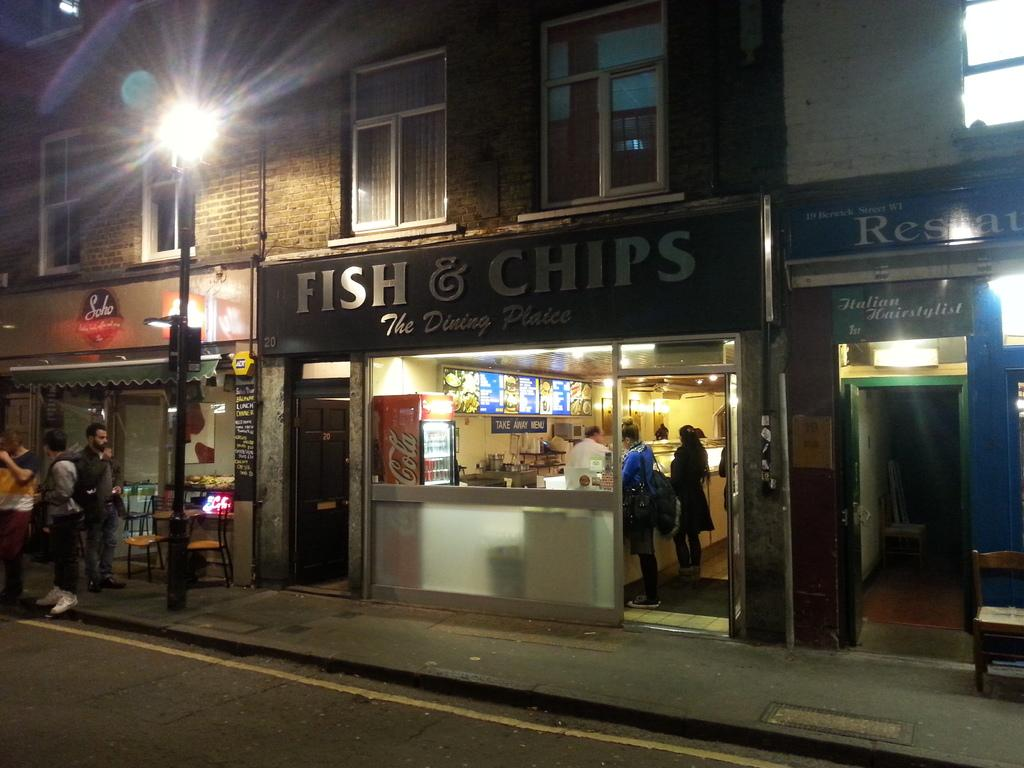What type of structures can be seen in the image? There are buildings in the image. What architectural features are visible on the buildings? There are windows in the image. What type of advertisements are present in the image? There are hoardings in the image. What type of establishments can be found in the image? There are stores in the image. Who or what is present in the image? There are people in the image. What type of furniture is visible in the image? There are chairs and tables in the image. What type of vertical structure is present in the image? There is a light pole in the image. What type of appliance can be seen in the image? There is a fridge in the image. What type of display is present in the image? There is a display in the image. What type of signage is present in the image? There are boards in the image. What type of access points are visible in the image? There are doors in the image. What type of illumination is present in the image? There are lights in the image. What type of objects are present in the image? There are objects in the image. What type of cloth is draped over the cake in the image? There is no cake present in the image, so there is no cloth draped over it. How many people are gathered in a group in the image? The image does not depict a group of people; it shows individuals in various settings. 